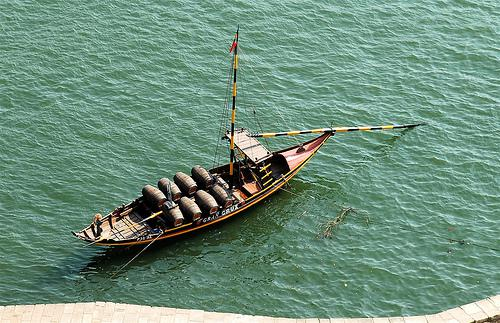Question: what is green?
Choices:
A. Water.
B. A house.
C. Grass.
D. The tree.
Answer with the letter. Answer: A Question: why is there a sail in the water?
Choices:
A. It is broken.
B. It is floating.
C. It is sinking.
D. It is drowning.
Answer with the letter. Answer: A Question: where is the anchor?
Choices:
A. In the front of the boat.
B. On the side of the boat.
C. In the back of the boat.
D. On the right side of the boat.
Answer with the letter. Answer: C 